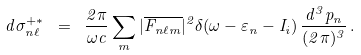Convert formula to latex. <formula><loc_0><loc_0><loc_500><loc_500>d \sigma ^ { + * } _ { n \ell } \ = \ \frac { 2 \pi } { \omega c } \sum _ { m } | \overline { F _ { n \ell m } } | ^ { 2 } \delta ( \omega - \varepsilon _ { n } - I _ { i } ) \, \frac { d ^ { 3 } p _ { n } } { ( 2 \pi ) ^ { 3 } } \, .</formula> 